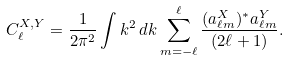Convert formula to latex. <formula><loc_0><loc_0><loc_500><loc_500>C _ { \ell } ^ { X , Y } = \frac { 1 } { 2 \pi ^ { 2 } } \int k ^ { 2 } \, d k \sum _ { m = - \ell } ^ { \ell } \frac { ( a _ { \ell m } ^ { X } ) ^ { \ast } a _ { \ell m } ^ { Y } } { ( 2 \ell + 1 ) } .</formula> 